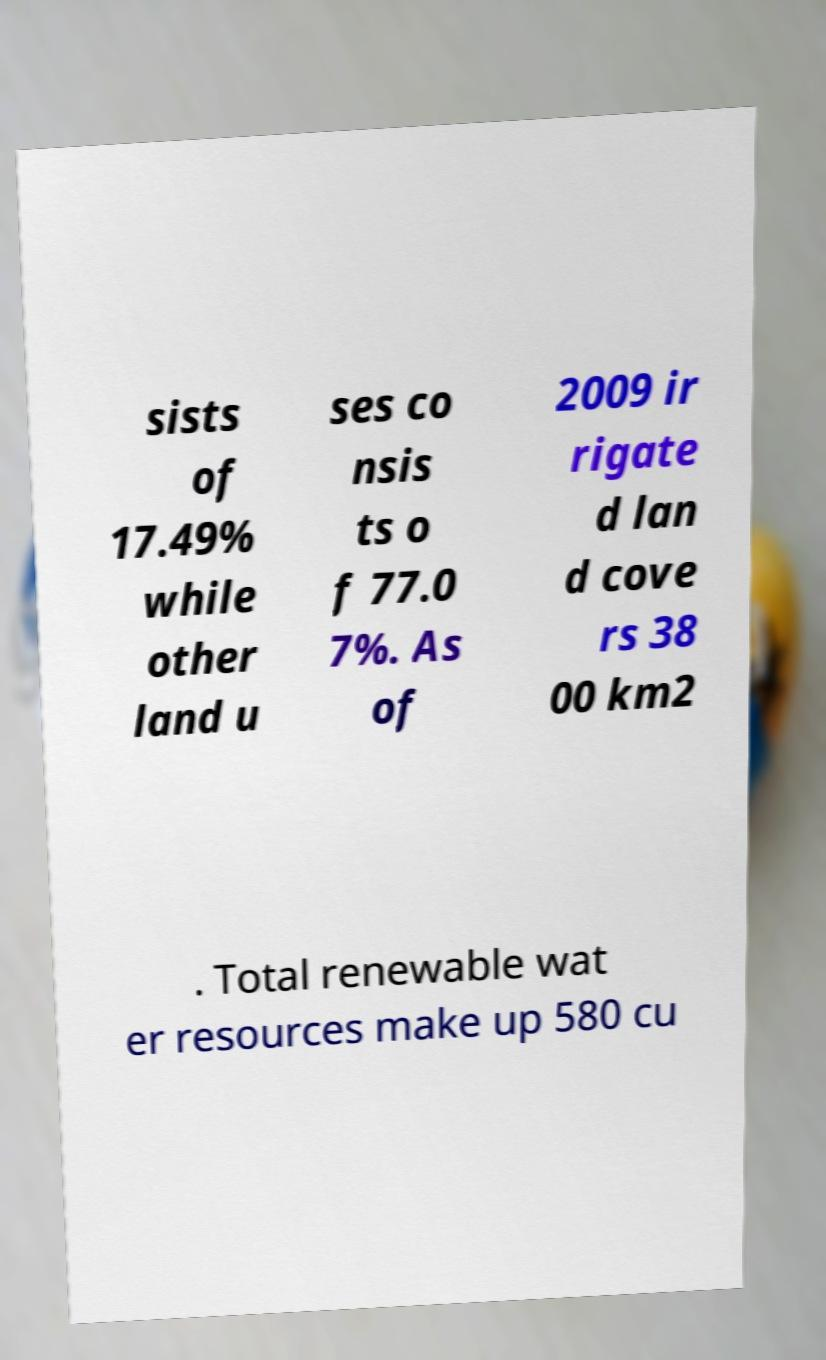Could you assist in decoding the text presented in this image and type it out clearly? sists of 17.49% while other land u ses co nsis ts o f 77.0 7%. As of 2009 ir rigate d lan d cove rs 38 00 km2 . Total renewable wat er resources make up 580 cu 